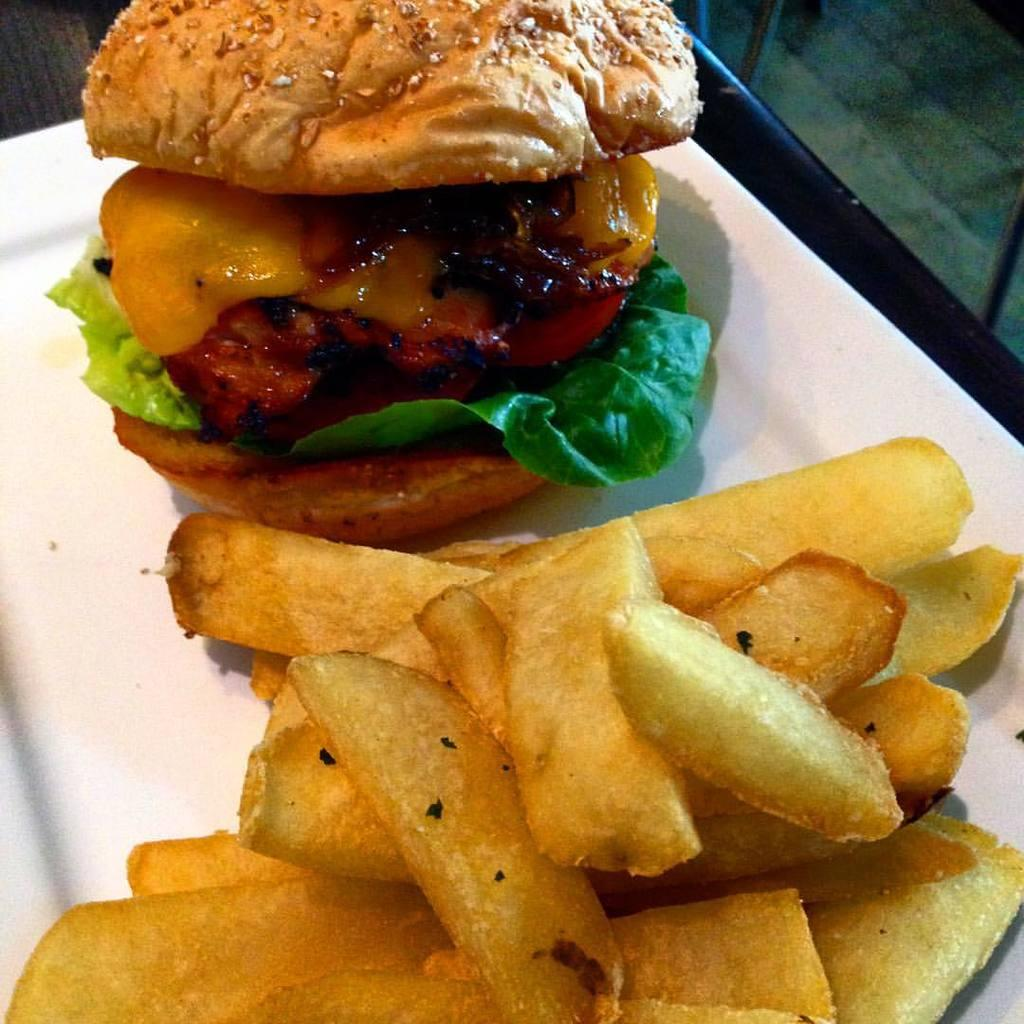What is on the plate that is visible in the image? The plate contains french fries and a bread sandwich. Where is the plate located in the image? The plate is placed on a table. What type of food is not present on the plate in the image? The image does not show any meat or vegetables other than the french fries. What type of iron is being used to press the governor's suit in the image? There is no iron or governor present in the image; it only shows a plate with french fries and a bread sandwich on a table. 